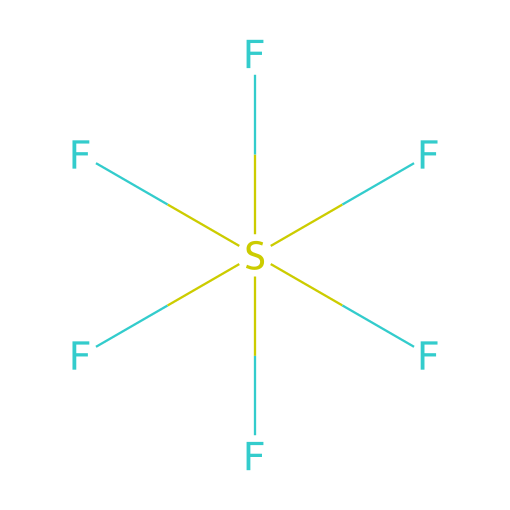How many fluorine atoms are present in sulfur hexafluoride? The SMILES representation shows that there are six fluorine (F) atoms attached to the sulfur (S) atom, as indicated by the six "F" symbols connected to the sulfur.
Answer: six What is the central atom in the structure of sulfur hexafluoride? The central element in the SMILES representation is sulfur (S), as it is the only atom that is the point of attachment for the six fluorine atoms.
Answer: sulfur How many total atoms are in sulfur hexafluoride? By counting the atoms in the SMILES representation, we find one sulfur atom and six fluorine atoms, totaling seven atoms.
Answer: seven What type of bond connects the fluorine atoms to the sulfur atom in sulfur hexafluoride? The bonding between the fluorine atoms and the sulfur atom is covalent. The strong electronegativity of fluorine leads to strong covalent bonds, typical in this structure.
Answer: covalent Why is sulfur hexafluoride considered an inert gas in practical applications? The structure of sulfur hexafluoride, with its full octet and high electronegativity of the surrounding fluorine atoms, contributes to its chemical inertness, meaning it does not readily react with other substances.
Answer: inert What is the molecular geometry of sulfur hexafluoride? The presence of six fluorine atoms bonded to one sulfur atom utilizes sp3d2 hybridization, leading to a molecular geometry identified as octahedral.
Answer: octahedral 